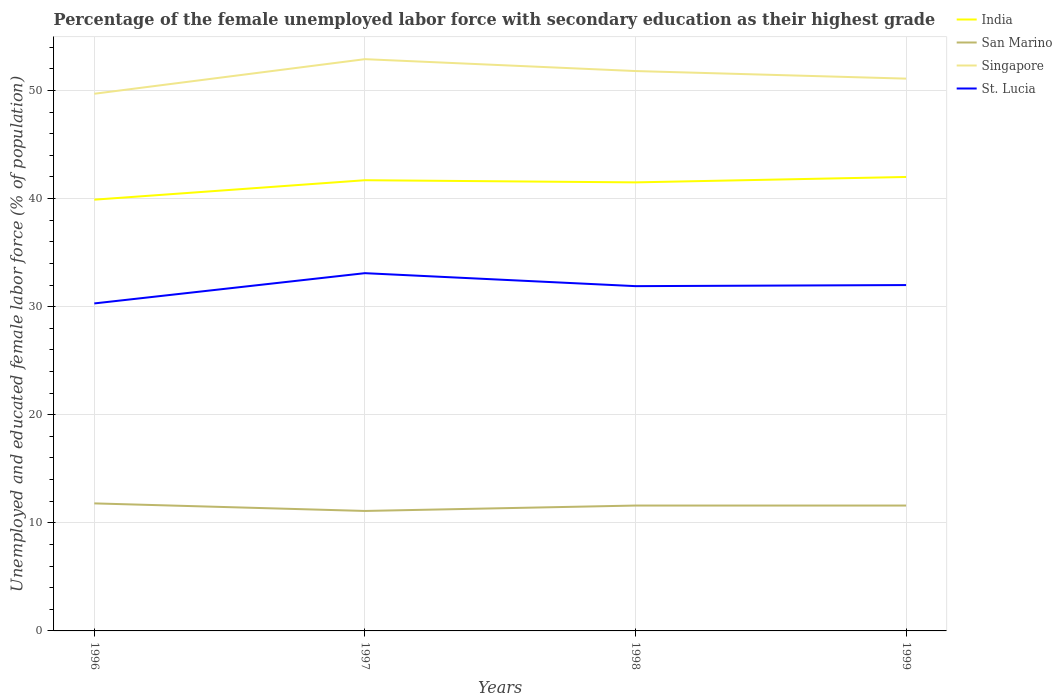Across all years, what is the maximum percentage of the unemployed female labor force with secondary education in India?
Your answer should be compact. 39.9. What is the difference between the highest and the second highest percentage of the unemployed female labor force with secondary education in India?
Keep it short and to the point. 2.1. What is the difference between the highest and the lowest percentage of the unemployed female labor force with secondary education in San Marino?
Offer a terse response. 3. How many lines are there?
Keep it short and to the point. 4. What is the difference between two consecutive major ticks on the Y-axis?
Your answer should be compact. 10. Are the values on the major ticks of Y-axis written in scientific E-notation?
Provide a short and direct response. No. Does the graph contain any zero values?
Make the answer very short. No. Does the graph contain grids?
Your answer should be compact. Yes. Where does the legend appear in the graph?
Provide a short and direct response. Top right. How many legend labels are there?
Your answer should be very brief. 4. What is the title of the graph?
Your response must be concise. Percentage of the female unemployed labor force with secondary education as their highest grade. Does "Morocco" appear as one of the legend labels in the graph?
Your answer should be very brief. No. What is the label or title of the X-axis?
Your answer should be very brief. Years. What is the label or title of the Y-axis?
Keep it short and to the point. Unemployed and educated female labor force (% of population). What is the Unemployed and educated female labor force (% of population) of India in 1996?
Provide a succinct answer. 39.9. What is the Unemployed and educated female labor force (% of population) in San Marino in 1996?
Offer a very short reply. 11.8. What is the Unemployed and educated female labor force (% of population) of Singapore in 1996?
Provide a succinct answer. 49.7. What is the Unemployed and educated female labor force (% of population) of St. Lucia in 1996?
Your answer should be very brief. 30.3. What is the Unemployed and educated female labor force (% of population) of India in 1997?
Give a very brief answer. 41.7. What is the Unemployed and educated female labor force (% of population) in San Marino in 1997?
Provide a short and direct response. 11.1. What is the Unemployed and educated female labor force (% of population) of Singapore in 1997?
Your response must be concise. 52.9. What is the Unemployed and educated female labor force (% of population) of St. Lucia in 1997?
Ensure brevity in your answer.  33.1. What is the Unemployed and educated female labor force (% of population) of India in 1998?
Ensure brevity in your answer.  41.5. What is the Unemployed and educated female labor force (% of population) in San Marino in 1998?
Offer a very short reply. 11.6. What is the Unemployed and educated female labor force (% of population) in Singapore in 1998?
Give a very brief answer. 51.8. What is the Unemployed and educated female labor force (% of population) of St. Lucia in 1998?
Ensure brevity in your answer.  31.9. What is the Unemployed and educated female labor force (% of population) in San Marino in 1999?
Provide a short and direct response. 11.6. What is the Unemployed and educated female labor force (% of population) of Singapore in 1999?
Your response must be concise. 51.1. Across all years, what is the maximum Unemployed and educated female labor force (% of population) in India?
Make the answer very short. 42. Across all years, what is the maximum Unemployed and educated female labor force (% of population) in San Marino?
Your response must be concise. 11.8. Across all years, what is the maximum Unemployed and educated female labor force (% of population) in Singapore?
Provide a succinct answer. 52.9. Across all years, what is the maximum Unemployed and educated female labor force (% of population) in St. Lucia?
Your answer should be compact. 33.1. Across all years, what is the minimum Unemployed and educated female labor force (% of population) of India?
Your response must be concise. 39.9. Across all years, what is the minimum Unemployed and educated female labor force (% of population) of San Marino?
Provide a succinct answer. 11.1. Across all years, what is the minimum Unemployed and educated female labor force (% of population) of Singapore?
Your response must be concise. 49.7. Across all years, what is the minimum Unemployed and educated female labor force (% of population) in St. Lucia?
Your response must be concise. 30.3. What is the total Unemployed and educated female labor force (% of population) in India in the graph?
Your answer should be compact. 165.1. What is the total Unemployed and educated female labor force (% of population) of San Marino in the graph?
Make the answer very short. 46.1. What is the total Unemployed and educated female labor force (% of population) in Singapore in the graph?
Your response must be concise. 205.5. What is the total Unemployed and educated female labor force (% of population) of St. Lucia in the graph?
Your answer should be compact. 127.3. What is the difference between the Unemployed and educated female labor force (% of population) of India in 1996 and that in 1997?
Your answer should be compact. -1.8. What is the difference between the Unemployed and educated female labor force (% of population) in San Marino in 1996 and that in 1997?
Provide a succinct answer. 0.7. What is the difference between the Unemployed and educated female labor force (% of population) in Singapore in 1996 and that in 1997?
Provide a succinct answer. -3.2. What is the difference between the Unemployed and educated female labor force (% of population) of St. Lucia in 1996 and that in 1997?
Offer a terse response. -2.8. What is the difference between the Unemployed and educated female labor force (% of population) in India in 1996 and that in 1998?
Make the answer very short. -1.6. What is the difference between the Unemployed and educated female labor force (% of population) of St. Lucia in 1996 and that in 1998?
Keep it short and to the point. -1.6. What is the difference between the Unemployed and educated female labor force (% of population) in India in 1996 and that in 1999?
Offer a terse response. -2.1. What is the difference between the Unemployed and educated female labor force (% of population) in India in 1997 and that in 1998?
Ensure brevity in your answer.  0.2. What is the difference between the Unemployed and educated female labor force (% of population) of San Marino in 1997 and that in 1998?
Your answer should be compact. -0.5. What is the difference between the Unemployed and educated female labor force (% of population) of St. Lucia in 1997 and that in 1998?
Give a very brief answer. 1.2. What is the difference between the Unemployed and educated female labor force (% of population) of India in 1997 and that in 1999?
Provide a short and direct response. -0.3. What is the difference between the Unemployed and educated female labor force (% of population) of San Marino in 1997 and that in 1999?
Your answer should be very brief. -0.5. What is the difference between the Unemployed and educated female labor force (% of population) of India in 1998 and that in 1999?
Provide a succinct answer. -0.5. What is the difference between the Unemployed and educated female labor force (% of population) in San Marino in 1998 and that in 1999?
Your response must be concise. 0. What is the difference between the Unemployed and educated female labor force (% of population) of Singapore in 1998 and that in 1999?
Offer a terse response. 0.7. What is the difference between the Unemployed and educated female labor force (% of population) of India in 1996 and the Unemployed and educated female labor force (% of population) of San Marino in 1997?
Keep it short and to the point. 28.8. What is the difference between the Unemployed and educated female labor force (% of population) in India in 1996 and the Unemployed and educated female labor force (% of population) in Singapore in 1997?
Offer a terse response. -13. What is the difference between the Unemployed and educated female labor force (% of population) in San Marino in 1996 and the Unemployed and educated female labor force (% of population) in Singapore in 1997?
Offer a very short reply. -41.1. What is the difference between the Unemployed and educated female labor force (% of population) in San Marino in 1996 and the Unemployed and educated female labor force (% of population) in St. Lucia in 1997?
Make the answer very short. -21.3. What is the difference between the Unemployed and educated female labor force (% of population) of Singapore in 1996 and the Unemployed and educated female labor force (% of population) of St. Lucia in 1997?
Keep it short and to the point. 16.6. What is the difference between the Unemployed and educated female labor force (% of population) in India in 1996 and the Unemployed and educated female labor force (% of population) in San Marino in 1998?
Give a very brief answer. 28.3. What is the difference between the Unemployed and educated female labor force (% of population) in India in 1996 and the Unemployed and educated female labor force (% of population) in Singapore in 1998?
Keep it short and to the point. -11.9. What is the difference between the Unemployed and educated female labor force (% of population) of San Marino in 1996 and the Unemployed and educated female labor force (% of population) of Singapore in 1998?
Your response must be concise. -40. What is the difference between the Unemployed and educated female labor force (% of population) of San Marino in 1996 and the Unemployed and educated female labor force (% of population) of St. Lucia in 1998?
Keep it short and to the point. -20.1. What is the difference between the Unemployed and educated female labor force (% of population) in Singapore in 1996 and the Unemployed and educated female labor force (% of population) in St. Lucia in 1998?
Offer a terse response. 17.8. What is the difference between the Unemployed and educated female labor force (% of population) in India in 1996 and the Unemployed and educated female labor force (% of population) in San Marino in 1999?
Offer a very short reply. 28.3. What is the difference between the Unemployed and educated female labor force (% of population) of India in 1996 and the Unemployed and educated female labor force (% of population) of Singapore in 1999?
Your response must be concise. -11.2. What is the difference between the Unemployed and educated female labor force (% of population) of San Marino in 1996 and the Unemployed and educated female labor force (% of population) of Singapore in 1999?
Your answer should be very brief. -39.3. What is the difference between the Unemployed and educated female labor force (% of population) of San Marino in 1996 and the Unemployed and educated female labor force (% of population) of St. Lucia in 1999?
Keep it short and to the point. -20.2. What is the difference between the Unemployed and educated female labor force (% of population) of India in 1997 and the Unemployed and educated female labor force (% of population) of San Marino in 1998?
Your answer should be compact. 30.1. What is the difference between the Unemployed and educated female labor force (% of population) in San Marino in 1997 and the Unemployed and educated female labor force (% of population) in Singapore in 1998?
Provide a short and direct response. -40.7. What is the difference between the Unemployed and educated female labor force (% of population) of San Marino in 1997 and the Unemployed and educated female labor force (% of population) of St. Lucia in 1998?
Offer a very short reply. -20.8. What is the difference between the Unemployed and educated female labor force (% of population) of India in 1997 and the Unemployed and educated female labor force (% of population) of San Marino in 1999?
Provide a short and direct response. 30.1. What is the difference between the Unemployed and educated female labor force (% of population) in India in 1997 and the Unemployed and educated female labor force (% of population) in St. Lucia in 1999?
Your answer should be compact. 9.7. What is the difference between the Unemployed and educated female labor force (% of population) of San Marino in 1997 and the Unemployed and educated female labor force (% of population) of Singapore in 1999?
Keep it short and to the point. -40. What is the difference between the Unemployed and educated female labor force (% of population) in San Marino in 1997 and the Unemployed and educated female labor force (% of population) in St. Lucia in 1999?
Give a very brief answer. -20.9. What is the difference between the Unemployed and educated female labor force (% of population) in Singapore in 1997 and the Unemployed and educated female labor force (% of population) in St. Lucia in 1999?
Provide a short and direct response. 20.9. What is the difference between the Unemployed and educated female labor force (% of population) of India in 1998 and the Unemployed and educated female labor force (% of population) of San Marino in 1999?
Offer a terse response. 29.9. What is the difference between the Unemployed and educated female labor force (% of population) of India in 1998 and the Unemployed and educated female labor force (% of population) of Singapore in 1999?
Your response must be concise. -9.6. What is the difference between the Unemployed and educated female labor force (% of population) of San Marino in 1998 and the Unemployed and educated female labor force (% of population) of Singapore in 1999?
Offer a terse response. -39.5. What is the difference between the Unemployed and educated female labor force (% of population) of San Marino in 1998 and the Unemployed and educated female labor force (% of population) of St. Lucia in 1999?
Your answer should be compact. -20.4. What is the difference between the Unemployed and educated female labor force (% of population) of Singapore in 1998 and the Unemployed and educated female labor force (% of population) of St. Lucia in 1999?
Provide a succinct answer. 19.8. What is the average Unemployed and educated female labor force (% of population) of India per year?
Ensure brevity in your answer.  41.27. What is the average Unemployed and educated female labor force (% of population) in San Marino per year?
Keep it short and to the point. 11.53. What is the average Unemployed and educated female labor force (% of population) of Singapore per year?
Provide a short and direct response. 51.38. What is the average Unemployed and educated female labor force (% of population) in St. Lucia per year?
Your response must be concise. 31.82. In the year 1996, what is the difference between the Unemployed and educated female labor force (% of population) in India and Unemployed and educated female labor force (% of population) in San Marino?
Give a very brief answer. 28.1. In the year 1996, what is the difference between the Unemployed and educated female labor force (% of population) of India and Unemployed and educated female labor force (% of population) of Singapore?
Your answer should be very brief. -9.8. In the year 1996, what is the difference between the Unemployed and educated female labor force (% of population) of India and Unemployed and educated female labor force (% of population) of St. Lucia?
Offer a very short reply. 9.6. In the year 1996, what is the difference between the Unemployed and educated female labor force (% of population) in San Marino and Unemployed and educated female labor force (% of population) in Singapore?
Offer a terse response. -37.9. In the year 1996, what is the difference between the Unemployed and educated female labor force (% of population) in San Marino and Unemployed and educated female labor force (% of population) in St. Lucia?
Give a very brief answer. -18.5. In the year 1996, what is the difference between the Unemployed and educated female labor force (% of population) of Singapore and Unemployed and educated female labor force (% of population) of St. Lucia?
Your answer should be very brief. 19.4. In the year 1997, what is the difference between the Unemployed and educated female labor force (% of population) of India and Unemployed and educated female labor force (% of population) of San Marino?
Offer a very short reply. 30.6. In the year 1997, what is the difference between the Unemployed and educated female labor force (% of population) of India and Unemployed and educated female labor force (% of population) of Singapore?
Offer a terse response. -11.2. In the year 1997, what is the difference between the Unemployed and educated female labor force (% of population) in India and Unemployed and educated female labor force (% of population) in St. Lucia?
Your response must be concise. 8.6. In the year 1997, what is the difference between the Unemployed and educated female labor force (% of population) of San Marino and Unemployed and educated female labor force (% of population) of Singapore?
Your response must be concise. -41.8. In the year 1997, what is the difference between the Unemployed and educated female labor force (% of population) in Singapore and Unemployed and educated female labor force (% of population) in St. Lucia?
Your answer should be compact. 19.8. In the year 1998, what is the difference between the Unemployed and educated female labor force (% of population) in India and Unemployed and educated female labor force (% of population) in San Marino?
Your answer should be compact. 29.9. In the year 1998, what is the difference between the Unemployed and educated female labor force (% of population) of India and Unemployed and educated female labor force (% of population) of Singapore?
Provide a short and direct response. -10.3. In the year 1998, what is the difference between the Unemployed and educated female labor force (% of population) in San Marino and Unemployed and educated female labor force (% of population) in Singapore?
Your answer should be very brief. -40.2. In the year 1998, what is the difference between the Unemployed and educated female labor force (% of population) in San Marino and Unemployed and educated female labor force (% of population) in St. Lucia?
Your answer should be very brief. -20.3. In the year 1999, what is the difference between the Unemployed and educated female labor force (% of population) in India and Unemployed and educated female labor force (% of population) in San Marino?
Ensure brevity in your answer.  30.4. In the year 1999, what is the difference between the Unemployed and educated female labor force (% of population) of India and Unemployed and educated female labor force (% of population) of Singapore?
Your response must be concise. -9.1. In the year 1999, what is the difference between the Unemployed and educated female labor force (% of population) of San Marino and Unemployed and educated female labor force (% of population) of Singapore?
Provide a succinct answer. -39.5. In the year 1999, what is the difference between the Unemployed and educated female labor force (% of population) of San Marino and Unemployed and educated female labor force (% of population) of St. Lucia?
Make the answer very short. -20.4. What is the ratio of the Unemployed and educated female labor force (% of population) in India in 1996 to that in 1997?
Provide a succinct answer. 0.96. What is the ratio of the Unemployed and educated female labor force (% of population) of San Marino in 1996 to that in 1997?
Provide a succinct answer. 1.06. What is the ratio of the Unemployed and educated female labor force (% of population) of Singapore in 1996 to that in 1997?
Provide a short and direct response. 0.94. What is the ratio of the Unemployed and educated female labor force (% of population) of St. Lucia in 1996 to that in 1997?
Ensure brevity in your answer.  0.92. What is the ratio of the Unemployed and educated female labor force (% of population) in India in 1996 to that in 1998?
Offer a terse response. 0.96. What is the ratio of the Unemployed and educated female labor force (% of population) in San Marino in 1996 to that in 1998?
Keep it short and to the point. 1.02. What is the ratio of the Unemployed and educated female labor force (% of population) of Singapore in 1996 to that in 1998?
Your answer should be very brief. 0.96. What is the ratio of the Unemployed and educated female labor force (% of population) of St. Lucia in 1996 to that in 1998?
Your answer should be very brief. 0.95. What is the ratio of the Unemployed and educated female labor force (% of population) of India in 1996 to that in 1999?
Your response must be concise. 0.95. What is the ratio of the Unemployed and educated female labor force (% of population) in San Marino in 1996 to that in 1999?
Your response must be concise. 1.02. What is the ratio of the Unemployed and educated female labor force (% of population) of Singapore in 1996 to that in 1999?
Make the answer very short. 0.97. What is the ratio of the Unemployed and educated female labor force (% of population) in St. Lucia in 1996 to that in 1999?
Keep it short and to the point. 0.95. What is the ratio of the Unemployed and educated female labor force (% of population) in San Marino in 1997 to that in 1998?
Provide a succinct answer. 0.96. What is the ratio of the Unemployed and educated female labor force (% of population) in Singapore in 1997 to that in 1998?
Provide a short and direct response. 1.02. What is the ratio of the Unemployed and educated female labor force (% of population) of St. Lucia in 1997 to that in 1998?
Your answer should be very brief. 1.04. What is the ratio of the Unemployed and educated female labor force (% of population) in San Marino in 1997 to that in 1999?
Keep it short and to the point. 0.96. What is the ratio of the Unemployed and educated female labor force (% of population) in Singapore in 1997 to that in 1999?
Provide a short and direct response. 1.04. What is the ratio of the Unemployed and educated female labor force (% of population) in St. Lucia in 1997 to that in 1999?
Ensure brevity in your answer.  1.03. What is the ratio of the Unemployed and educated female labor force (% of population) of Singapore in 1998 to that in 1999?
Give a very brief answer. 1.01. What is the ratio of the Unemployed and educated female labor force (% of population) of St. Lucia in 1998 to that in 1999?
Offer a very short reply. 1. What is the difference between the highest and the second highest Unemployed and educated female labor force (% of population) in San Marino?
Offer a terse response. 0.2. What is the difference between the highest and the lowest Unemployed and educated female labor force (% of population) of India?
Your answer should be compact. 2.1. What is the difference between the highest and the lowest Unemployed and educated female labor force (% of population) in San Marino?
Provide a short and direct response. 0.7. What is the difference between the highest and the lowest Unemployed and educated female labor force (% of population) of Singapore?
Make the answer very short. 3.2. What is the difference between the highest and the lowest Unemployed and educated female labor force (% of population) of St. Lucia?
Keep it short and to the point. 2.8. 